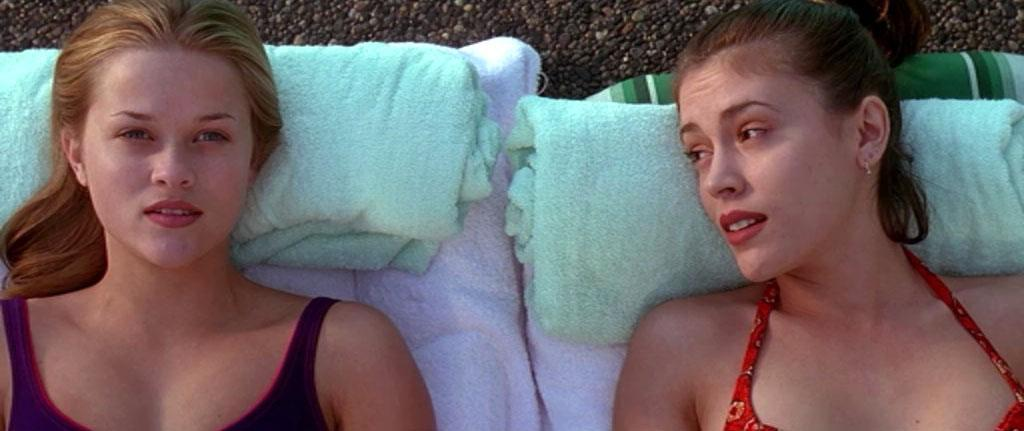What are the women doing in the image? The women are lying on towels in the image. How are the women positioned on the towels? The women have towels wrapped under their heads. What can be seen in the background of the image? There is a rough dark surface in the background of the image. What type of growth can be seen on the wall in the image? There is no wall or growth present in the image. Is there a cactus visible in the image? There is no cactus present in the image. 